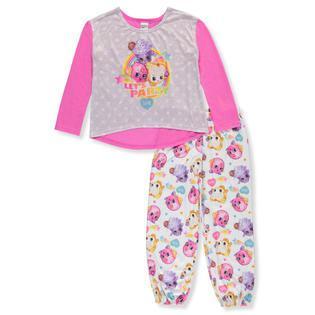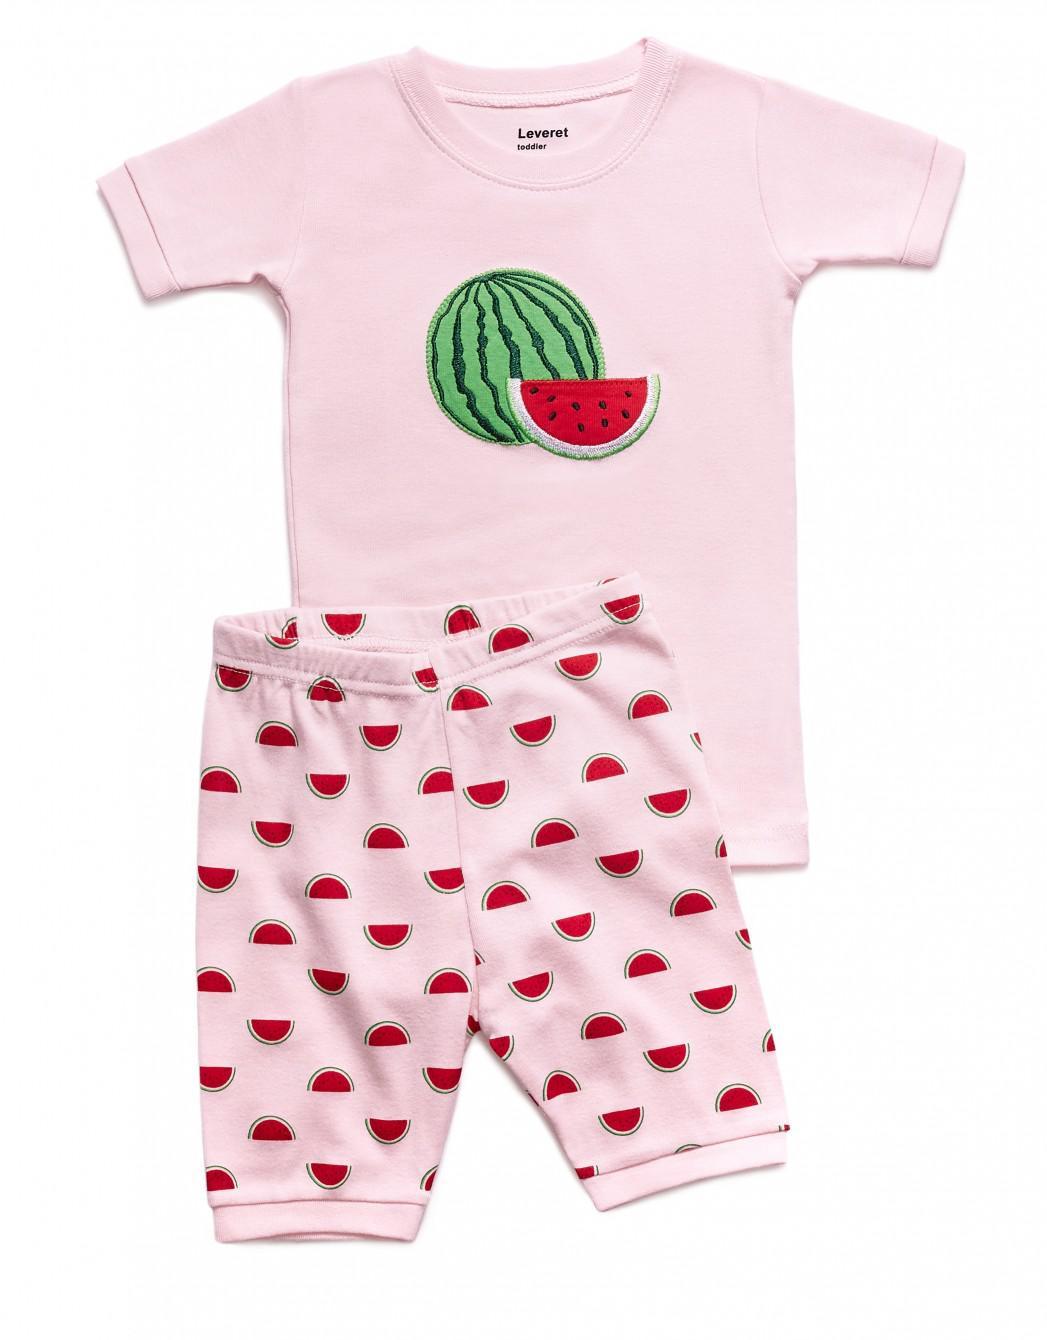The first image is the image on the left, the second image is the image on the right. For the images shown, is this caption "a pair of pajamas has short sleeves and long pants" true? Answer yes or no. No. The first image is the image on the left, the second image is the image on the right. Considering the images on both sides, is "There is one pair of shorts and one pair of pants." valid? Answer yes or no. Yes. 